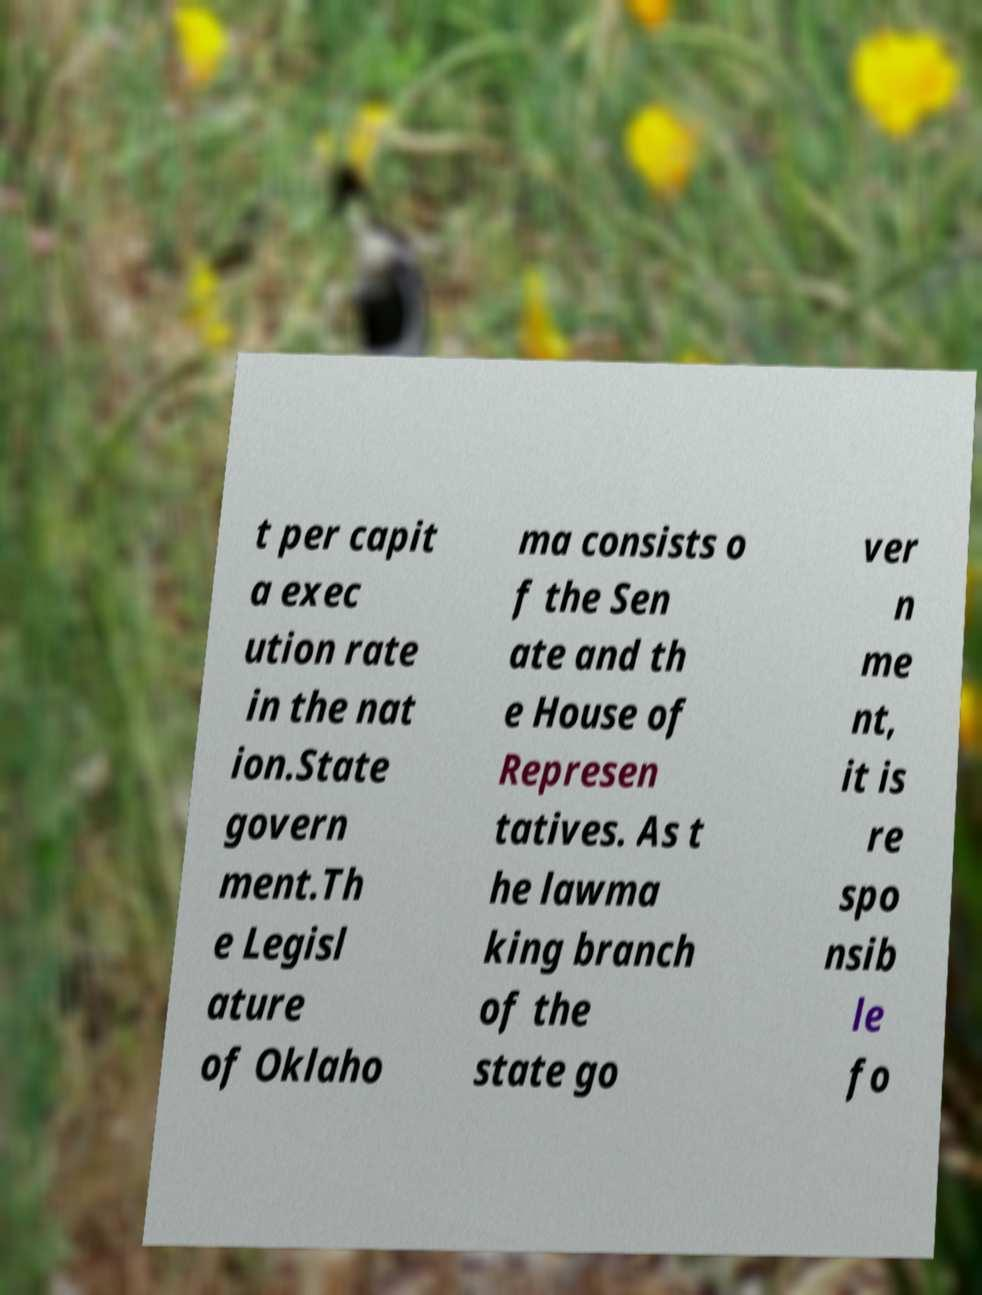What messages or text are displayed in this image? I need them in a readable, typed format. t per capit a exec ution rate in the nat ion.State govern ment.Th e Legisl ature of Oklaho ma consists o f the Sen ate and th e House of Represen tatives. As t he lawma king branch of the state go ver n me nt, it is re spo nsib le fo 